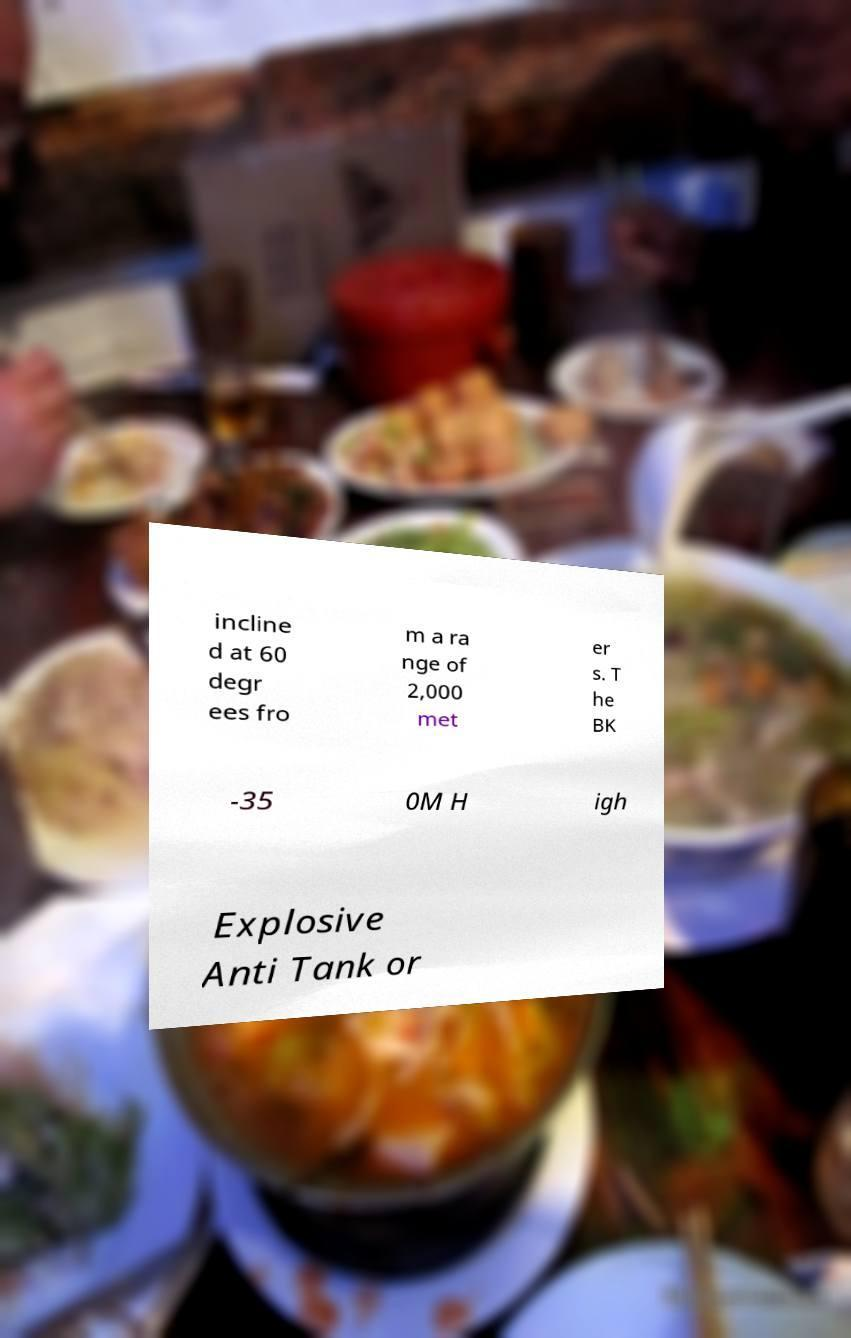Can you read and provide the text displayed in the image?This photo seems to have some interesting text. Can you extract and type it out for me? incline d at 60 degr ees fro m a ra nge of 2,000 met er s. T he BK -35 0M H igh Explosive Anti Tank or 